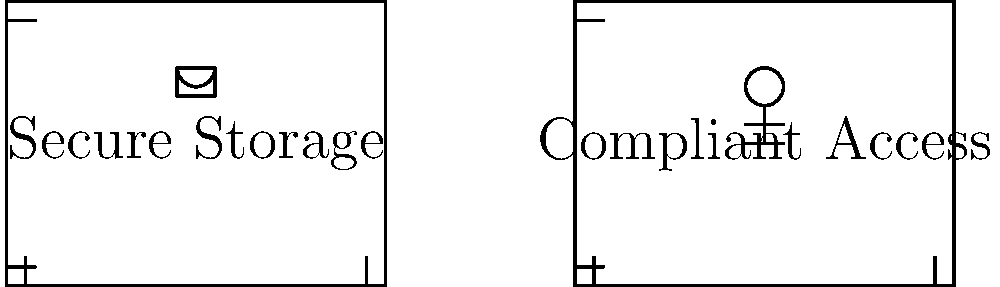The diagram shows two congruent rectangles representing aspects of digital employee record management. If the area of the "Secure Storage" rectangle is 12 square units, what is the combined perimeter of both rectangles? To solve this problem, let's follow these steps:

1. Understand the congruence: Since the rectangles are congruent, they have the same dimensions.

2. Calculate the dimensions:
   - Area of "Secure Storage" rectangle = 12 square units
   - Let the width be $w$ and height be $h$
   - Area formula: $A = w \times h = 12$

3. Determine the ratio:
   - Observing the diagram, the width seems to be 4/3 of the height
   - Let's express this as: $w = \frac{4}{3}h$

4. Solve for dimensions:
   - Substitute into area formula: $\frac{4}{3}h \times h = 12$
   - Simplify: $\frac{4}{3}h^2 = 12$
   - Solve for $h$: $h^2 = 9$, so $h = 3$
   - Calculate $w$: $w = \frac{4}{3} \times 3 = 4$

5. Calculate perimeter of one rectangle:
   - Perimeter = $2(w + h) = 2(4 + 3) = 2(7) = 14$ units

6. Calculate combined perimeter:
   - Combined perimeter = $2 \times 14 = 28$ units

Therefore, the combined perimeter of both rectangles is 28 units.
Answer: 28 units 